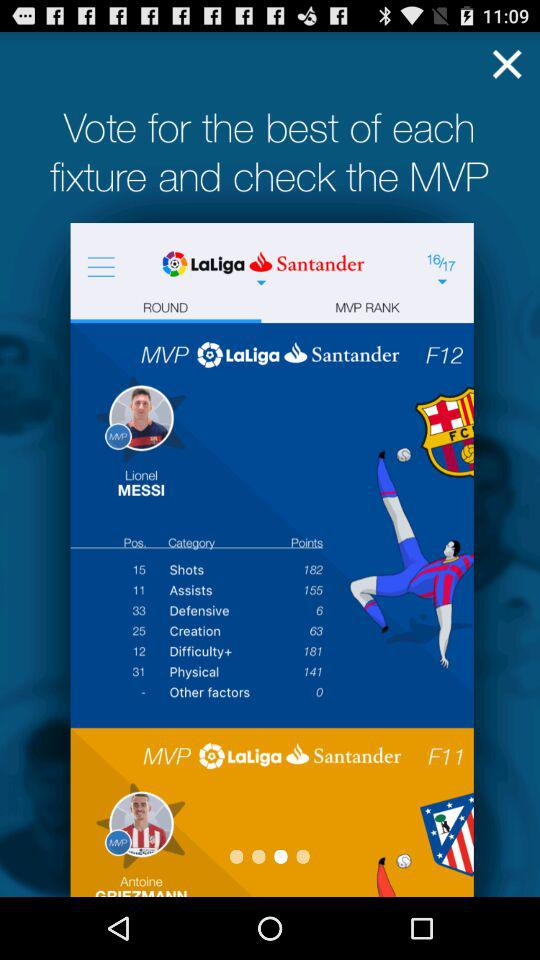What is the team name?
When the provided information is insufficient, respond with <no answer>. <no answer> 